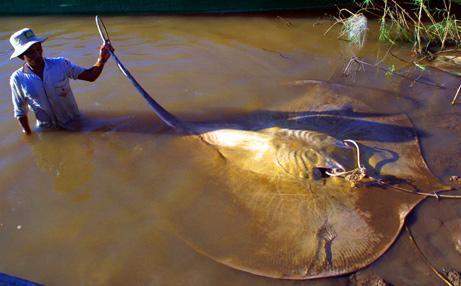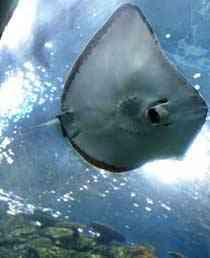The first image is the image on the left, the second image is the image on the right. Examine the images to the left and right. Is the description "An image shows a round-shaped stingray with an all-over pattern of distinctive spots." accurate? Answer yes or no. No. The first image is the image on the left, the second image is the image on the right. Examine the images to the left and right. Is the description "The tail of the animal in the image on the left touches the left side of the image." accurate? Answer yes or no. No. 